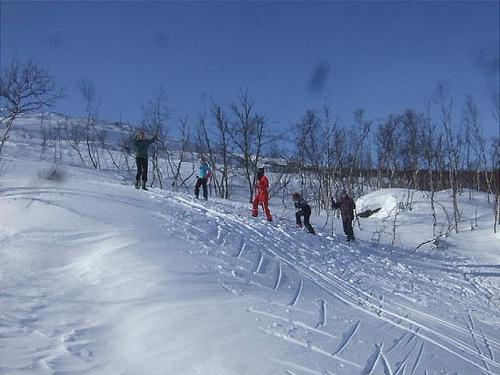Question: what are these people doing?
Choices:
A. Skiing.
B. Swimming.
C. Walking.
D. Running.
Answer with the letter. Answer: A Question: when was this photo taken?
Choices:
A. Fall.
B. Spring.
C. During the winter months.
D. Summer.
Answer with the letter. Answer: C Question: where was this photo taken?
Choices:
A. Mountain.
B. Outside, in the snow.
C. Farm.
D. Cabin.
Answer with the letter. Answer: B Question: what tracks are in the snow?
Choices:
A. Footprints.
B. Ski tracks.
C. Snow shoe.
D. Bear.
Answer with the letter. Answer: B Question: who is the focus of this photo?
Choices:
A. A group of soccer players.
B. A group of kayakers.
C. A group of skaters.
D. A group of skiers.
Answer with the letter. Answer: D 